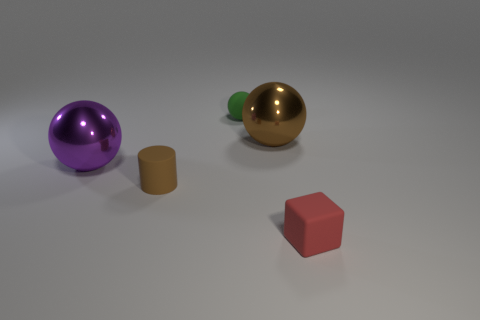Add 3 large metallic things. How many objects exist? 8 Subtract all cylinders. How many objects are left? 4 Subtract all big blue cylinders. Subtract all tiny matte things. How many objects are left? 2 Add 2 red rubber objects. How many red rubber objects are left? 3 Add 5 tiny green things. How many tiny green things exist? 6 Subtract 0 green cubes. How many objects are left? 5 